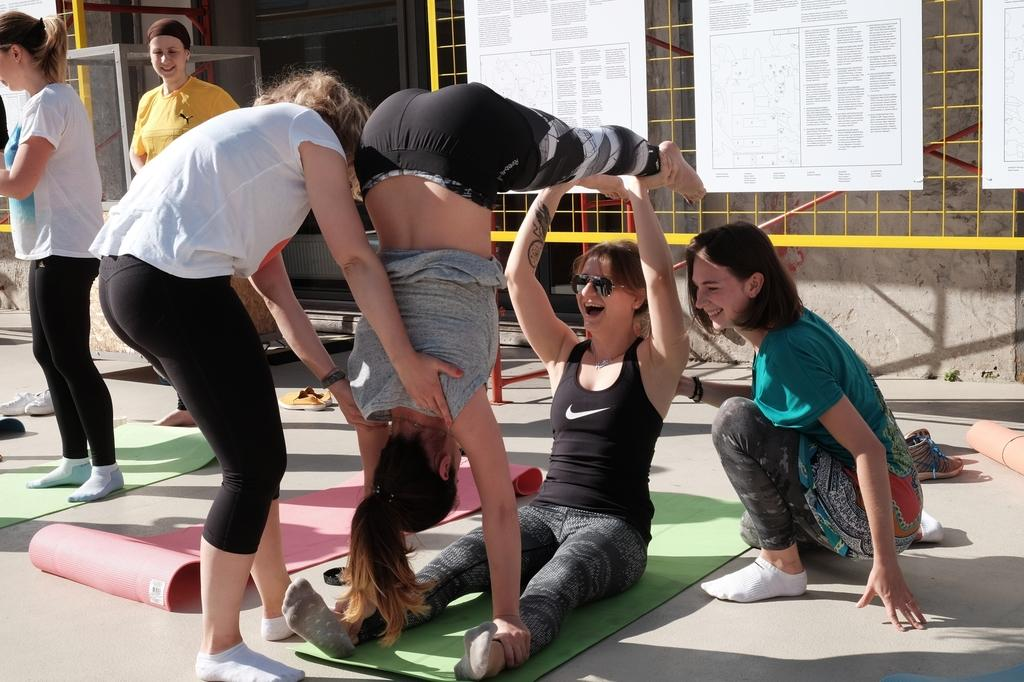How many people are in the image? There is a group of people in the image, but the exact number cannot be determined from the provided facts. What are the people standing or sitting on in the image? There are mats in the image, which the people might be using. What is on the floor near the people in the image? Footwear is present on the floor in the image. What can be seen in the background of the image? There are boards visible in the background of the image, as well as other objects. Can you see a hole in the lake in the image? There is no lake present in the image, so it is not possible to see a hole in it. 